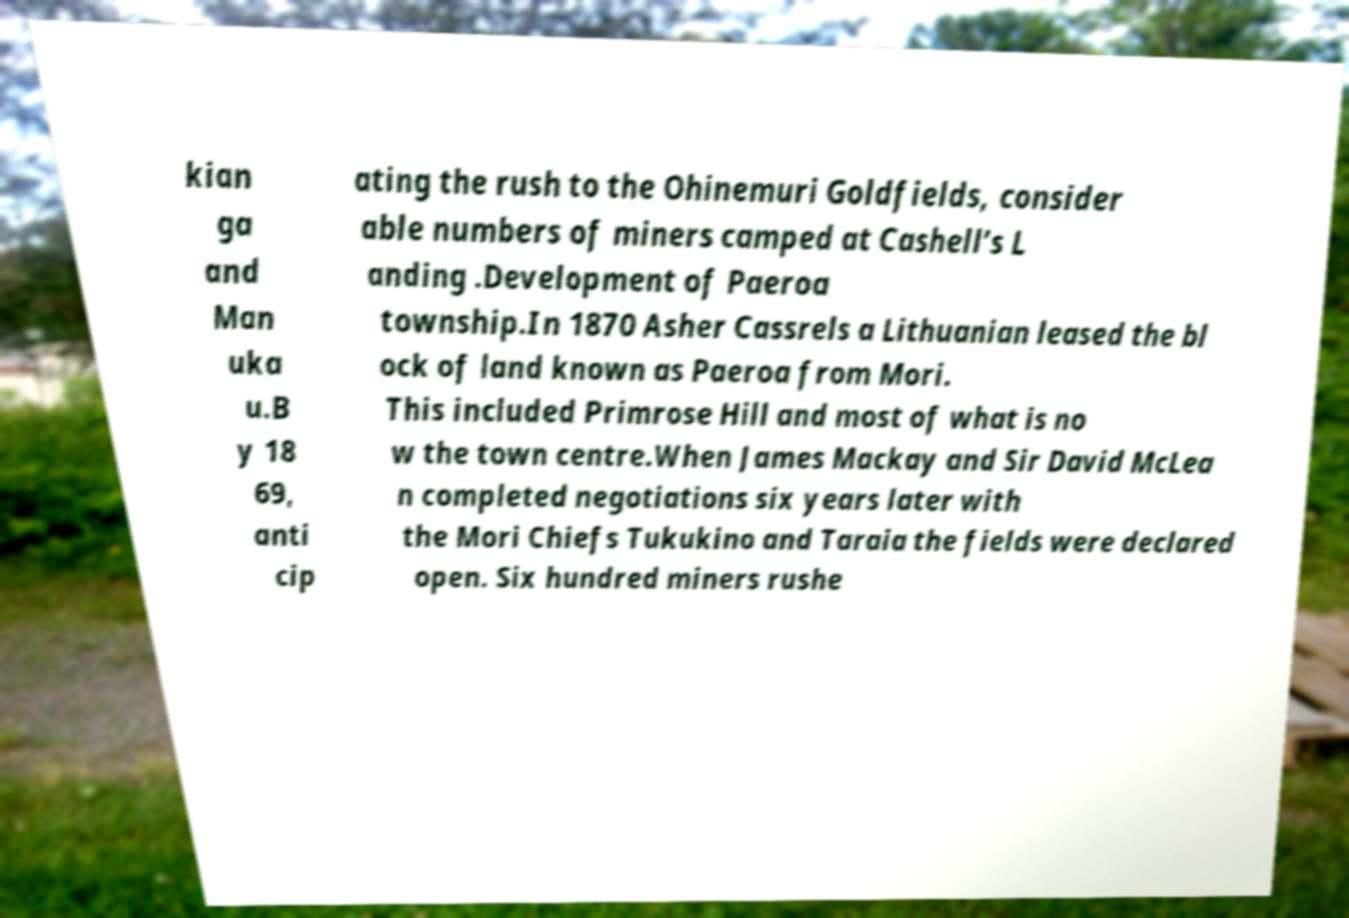Can you read and provide the text displayed in the image?This photo seems to have some interesting text. Can you extract and type it out for me? kian ga and Man uka u.B y 18 69, anti cip ating the rush to the Ohinemuri Goldfields, consider able numbers of miners camped at Cashell’s L anding .Development of Paeroa township.In 1870 Asher Cassrels a Lithuanian leased the bl ock of land known as Paeroa from Mori. This included Primrose Hill and most of what is no w the town centre.When James Mackay and Sir David McLea n completed negotiations six years later with the Mori Chiefs Tukukino and Taraia the fields were declared open. Six hundred miners rushe 